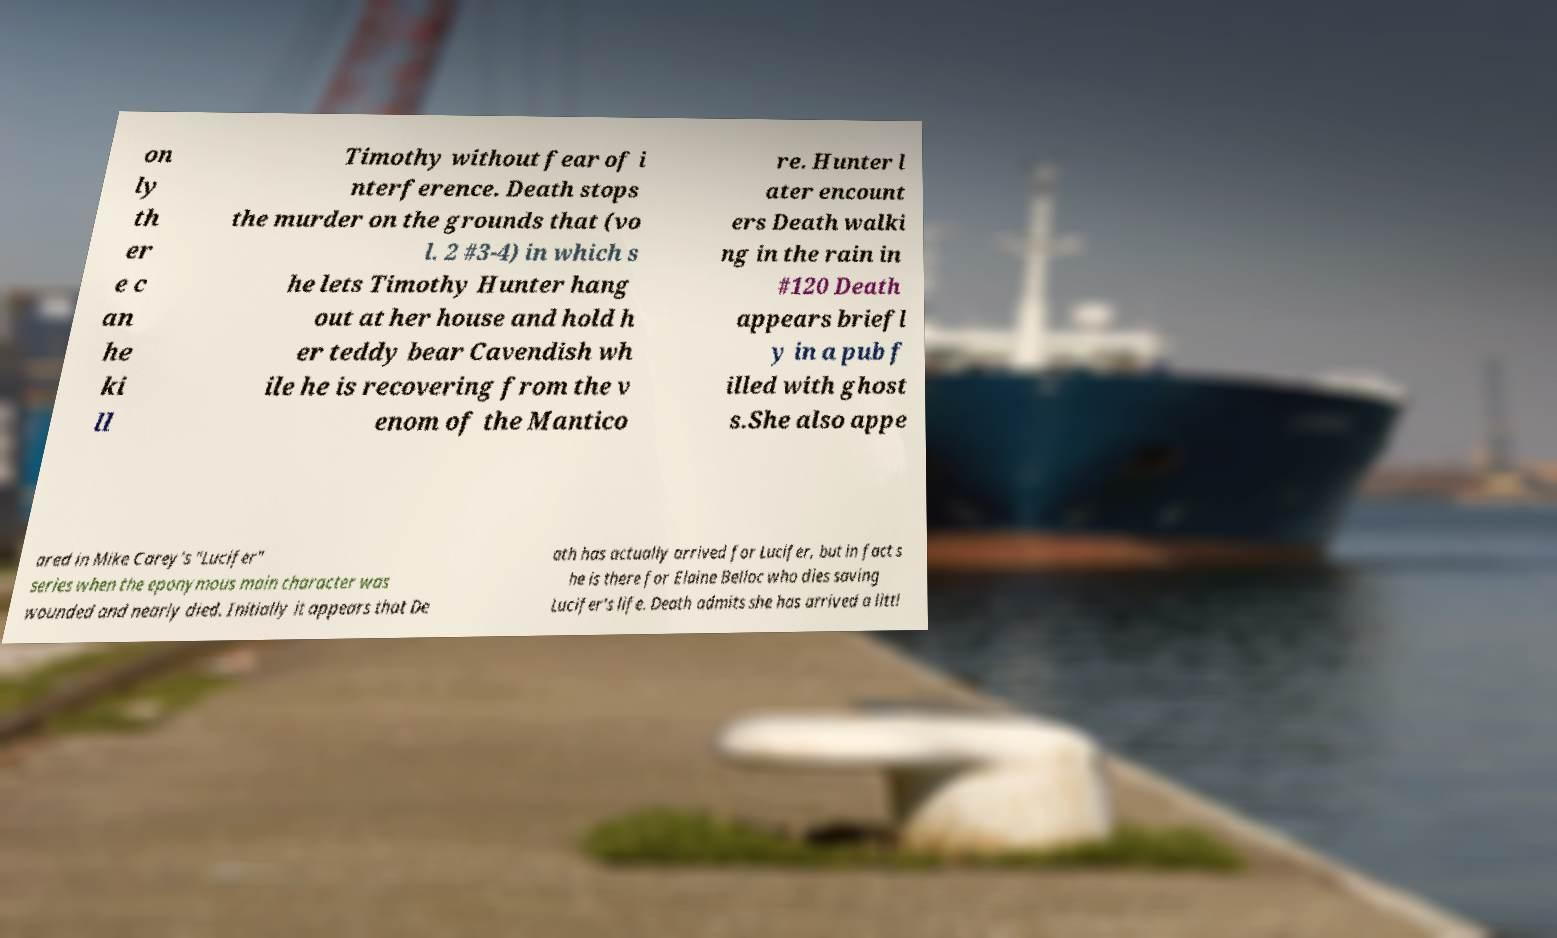I need the written content from this picture converted into text. Can you do that? on ly th er e c an he ki ll Timothy without fear of i nterference. Death stops the murder on the grounds that (vo l. 2 #3-4) in which s he lets Timothy Hunter hang out at her house and hold h er teddy bear Cavendish wh ile he is recovering from the v enom of the Mantico re. Hunter l ater encount ers Death walki ng in the rain in #120 Death appears briefl y in a pub f illed with ghost s.She also appe ared in Mike Carey's "Lucifer" series when the eponymous main character was wounded and nearly died. Initially it appears that De ath has actually arrived for Lucifer, but in fact s he is there for Elaine Belloc who dies saving Lucifer's life. Death admits she has arrived a littl 